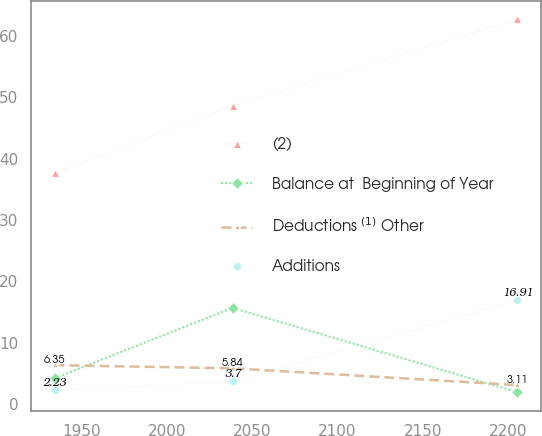Convert chart. <chart><loc_0><loc_0><loc_500><loc_500><line_chart><ecel><fcel>(2)<fcel>Balance at  Beginning of Year<fcel>Deductions $^{(1)}$ Other<fcel>Additions<nl><fcel>1934.16<fcel>37.65<fcel>4.21<fcel>6.35<fcel>2.23<nl><fcel>2038.5<fcel>48.66<fcel>15.69<fcel>5.84<fcel>3.7<nl><fcel>2205.4<fcel>62.73<fcel>1.93<fcel>3.11<fcel>16.91<nl></chart> 